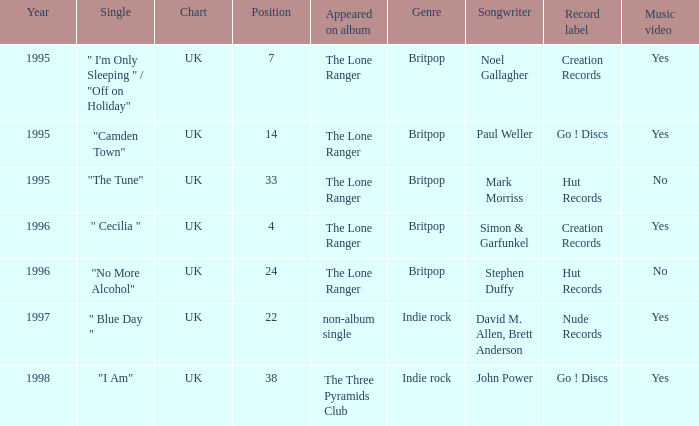After 1996, what is the average position? 30.0. I'm looking to parse the entire table for insights. Could you assist me with that? {'header': ['Year', 'Single', 'Chart', 'Position', 'Appeared on album', 'Genre', 'Songwriter', 'Record label', 'Music video'], 'rows': [['1995', '" I\'m Only Sleeping " / "Off on Holiday"', 'UK', '7', 'The Lone Ranger', 'Britpop', 'Noel Gallagher', 'Creation Records', 'Yes'], ['1995', '"Camden Town"', 'UK', '14', 'The Lone Ranger', 'Britpop', 'Paul Weller', 'Go ! Discs', 'Yes'], ['1995', '"The Tune"', 'UK', '33', 'The Lone Ranger', 'Britpop', 'Mark Morriss', 'Hut Records', 'No'], ['1996', '" Cecilia "', 'UK', '4', 'The Lone Ranger', 'Britpop', 'Simon & Garfunkel', 'Creation Records', 'Yes'], ['1996', '"No More Alcohol"', 'UK', '24', 'The Lone Ranger', 'Britpop', 'Stephen Duffy', 'Hut Records', 'No'], ['1997', '" Blue Day "', 'UK', '22', 'non-album single', 'Indie rock', 'David M. Allen, Brett Anderson', 'Nude Records', 'Yes'], ['1998', '"I Am"', 'UK', '38', 'The Three Pyramids Club', 'Indie rock', 'John Power', 'Go ! Discs', 'Yes']]} 